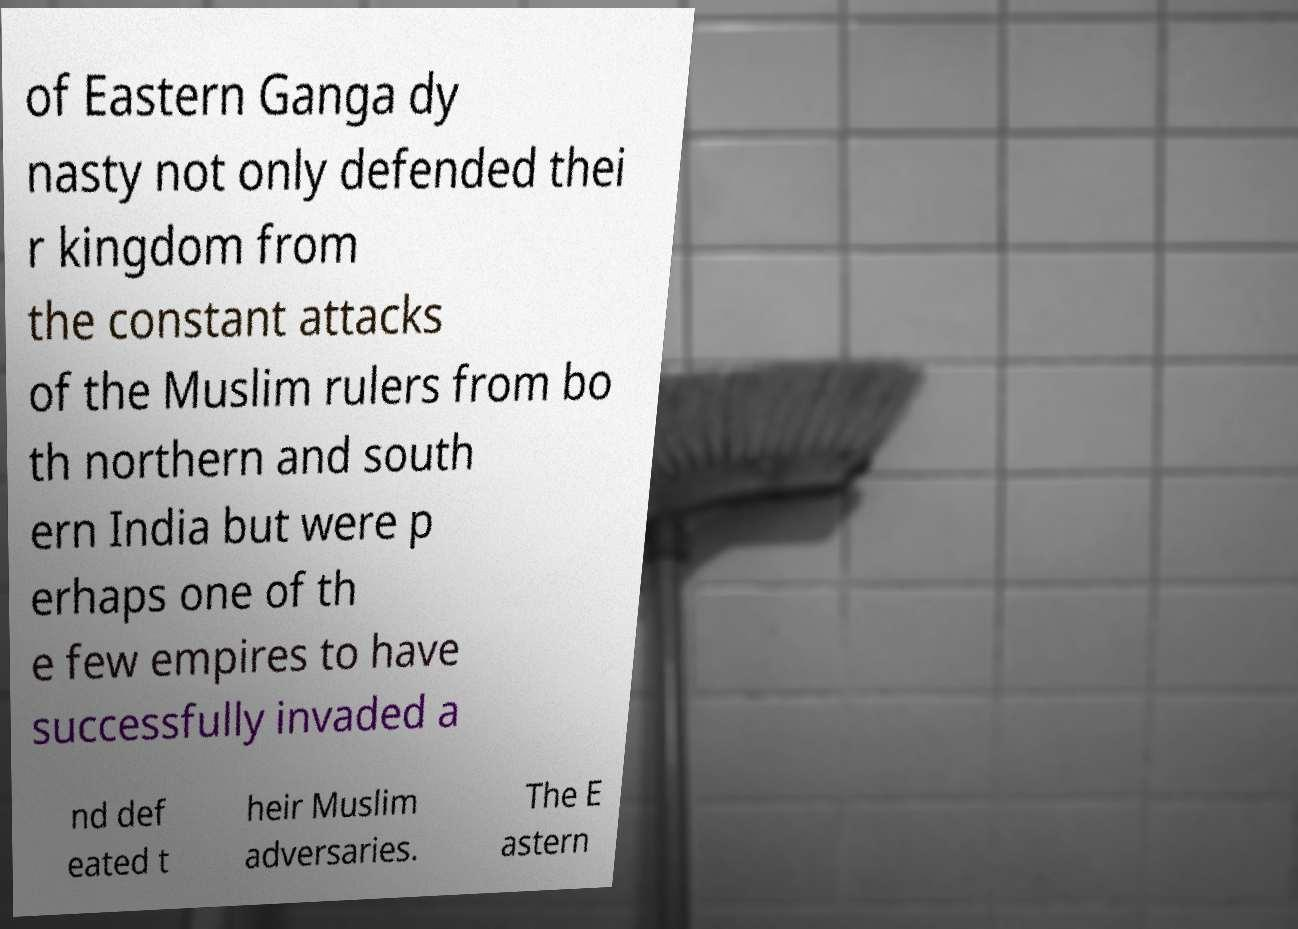Please read and relay the text visible in this image. What does it say? of Eastern Ganga dy nasty not only defended thei r kingdom from the constant attacks of the Muslim rulers from bo th northern and south ern India but were p erhaps one of th e few empires to have successfully invaded a nd def eated t heir Muslim adversaries. The E astern 